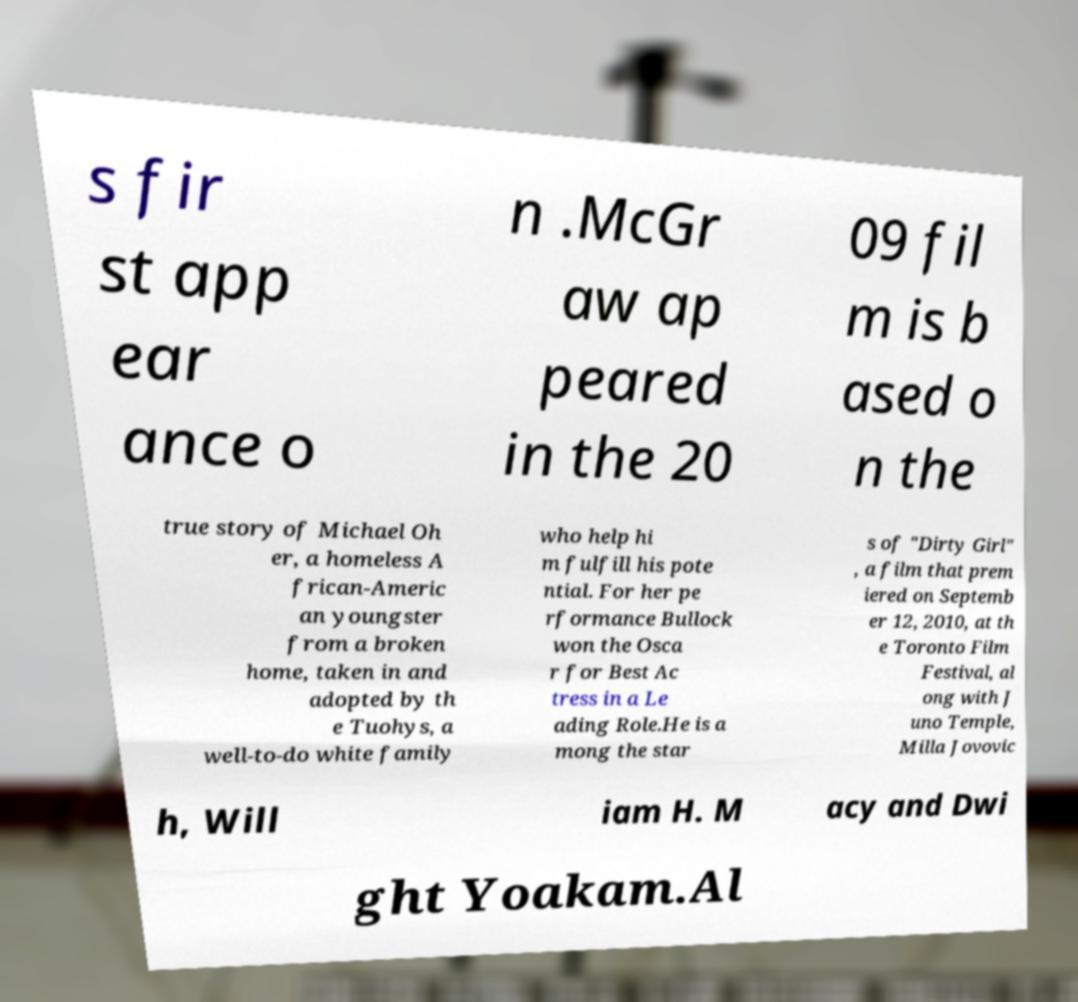Please read and relay the text visible in this image. What does it say? s fir st app ear ance o n .McGr aw ap peared in the 20 09 fil m is b ased o n the true story of Michael Oh er, a homeless A frican-Americ an youngster from a broken home, taken in and adopted by th e Tuohys, a well-to-do white family who help hi m fulfill his pote ntial. For her pe rformance Bullock won the Osca r for Best Ac tress in a Le ading Role.He is a mong the star s of "Dirty Girl" , a film that prem iered on Septemb er 12, 2010, at th e Toronto Film Festival, al ong with J uno Temple, Milla Jovovic h, Will iam H. M acy and Dwi ght Yoakam.Al 